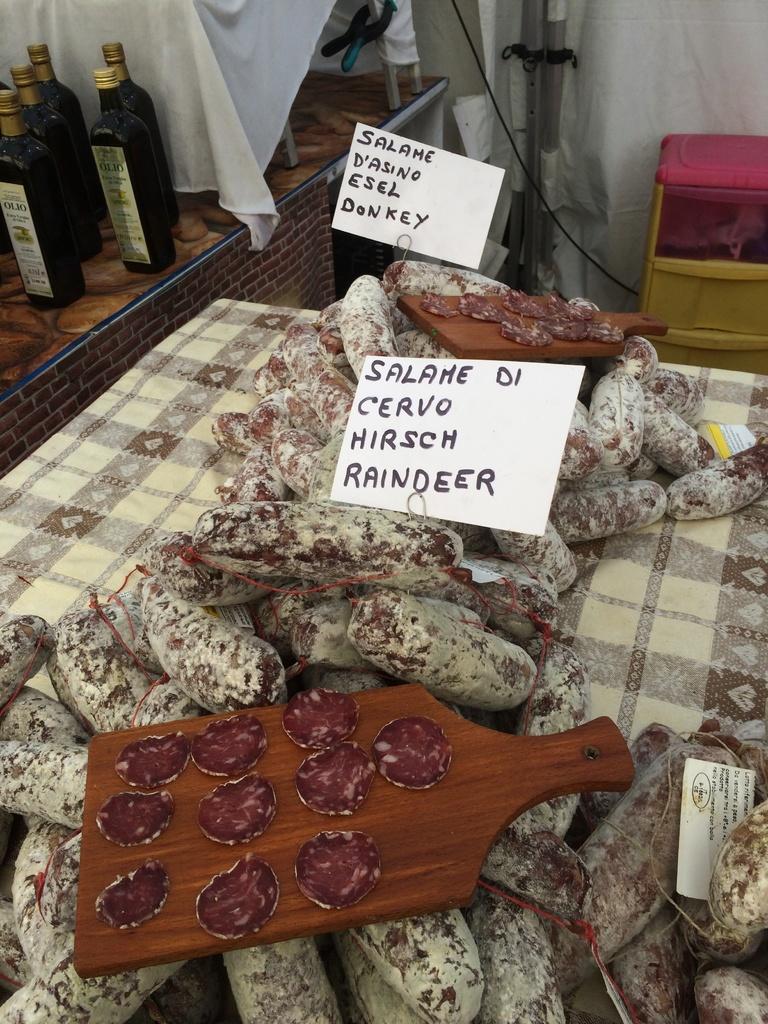What is the bottom word on the list?
Your answer should be very brief. Raindeer. 